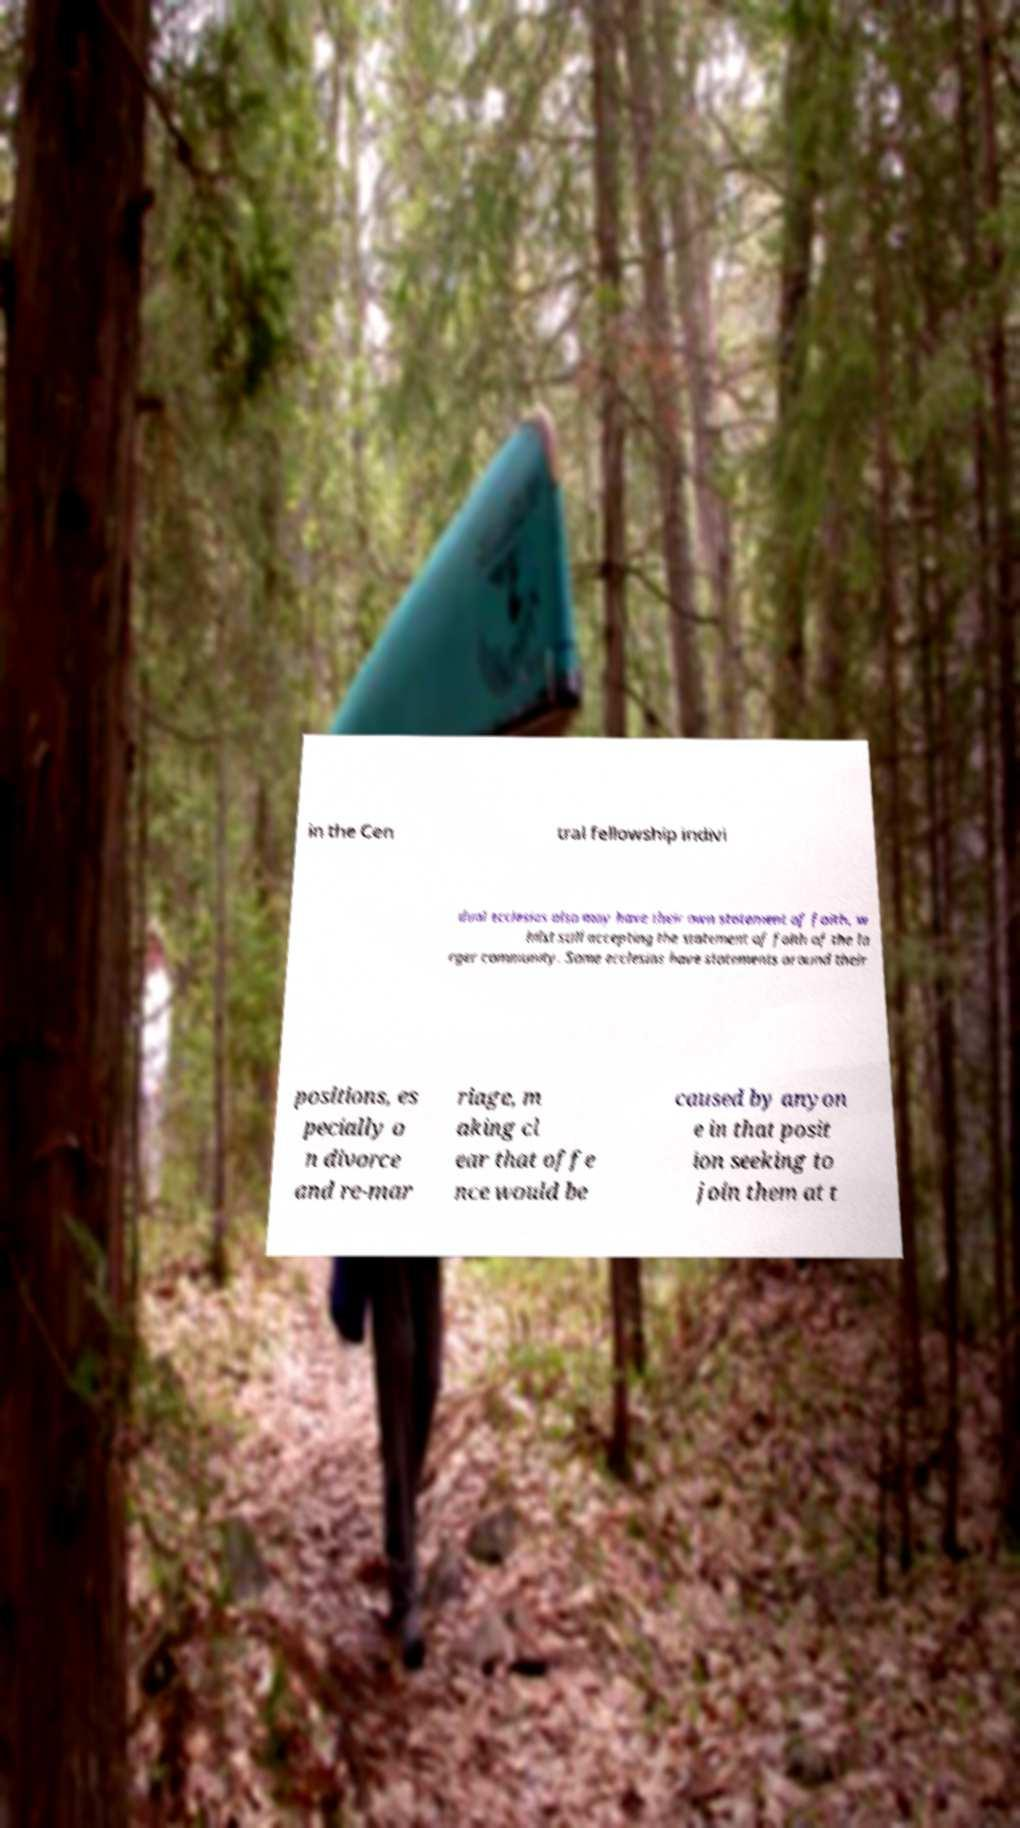Could you assist in decoding the text presented in this image and type it out clearly? in the Cen tral fellowship indivi dual ecclesias also may have their own statement of faith, w hilst still accepting the statement of faith of the la rger community. Some ecclesias have statements around their positions, es pecially o n divorce and re-mar riage, m aking cl ear that offe nce would be caused by anyon e in that posit ion seeking to join them at t 